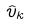Convert formula to latex. <formula><loc_0><loc_0><loc_500><loc_500>\hat { v } _ { k }</formula> 